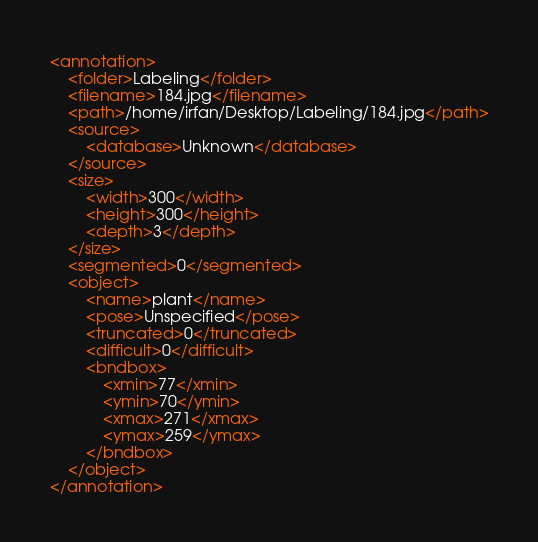Convert code to text. <code><loc_0><loc_0><loc_500><loc_500><_XML_><annotation>
	<folder>Labeling</folder>
	<filename>184.jpg</filename>
	<path>/home/irfan/Desktop/Labeling/184.jpg</path>
	<source>
		<database>Unknown</database>
	</source>
	<size>
		<width>300</width>
		<height>300</height>
		<depth>3</depth>
	</size>
	<segmented>0</segmented>
	<object>
		<name>plant</name>
		<pose>Unspecified</pose>
		<truncated>0</truncated>
		<difficult>0</difficult>
		<bndbox>
			<xmin>77</xmin>
			<ymin>70</ymin>
			<xmax>271</xmax>
			<ymax>259</ymax>
		</bndbox>
	</object>
</annotation>
</code> 